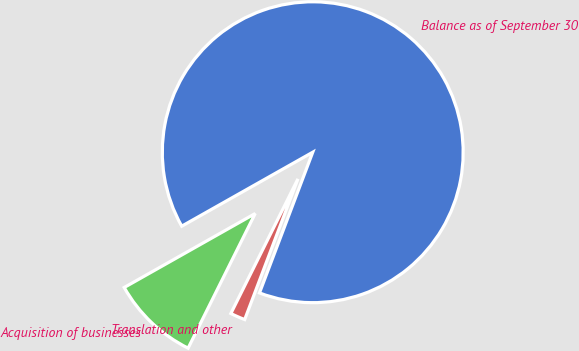Convert chart. <chart><loc_0><loc_0><loc_500><loc_500><pie_chart><fcel>Balance as of September 30<fcel>Acquisition of businesses<fcel>Translation and other<nl><fcel>88.94%<fcel>9.46%<fcel>1.6%<nl></chart> 